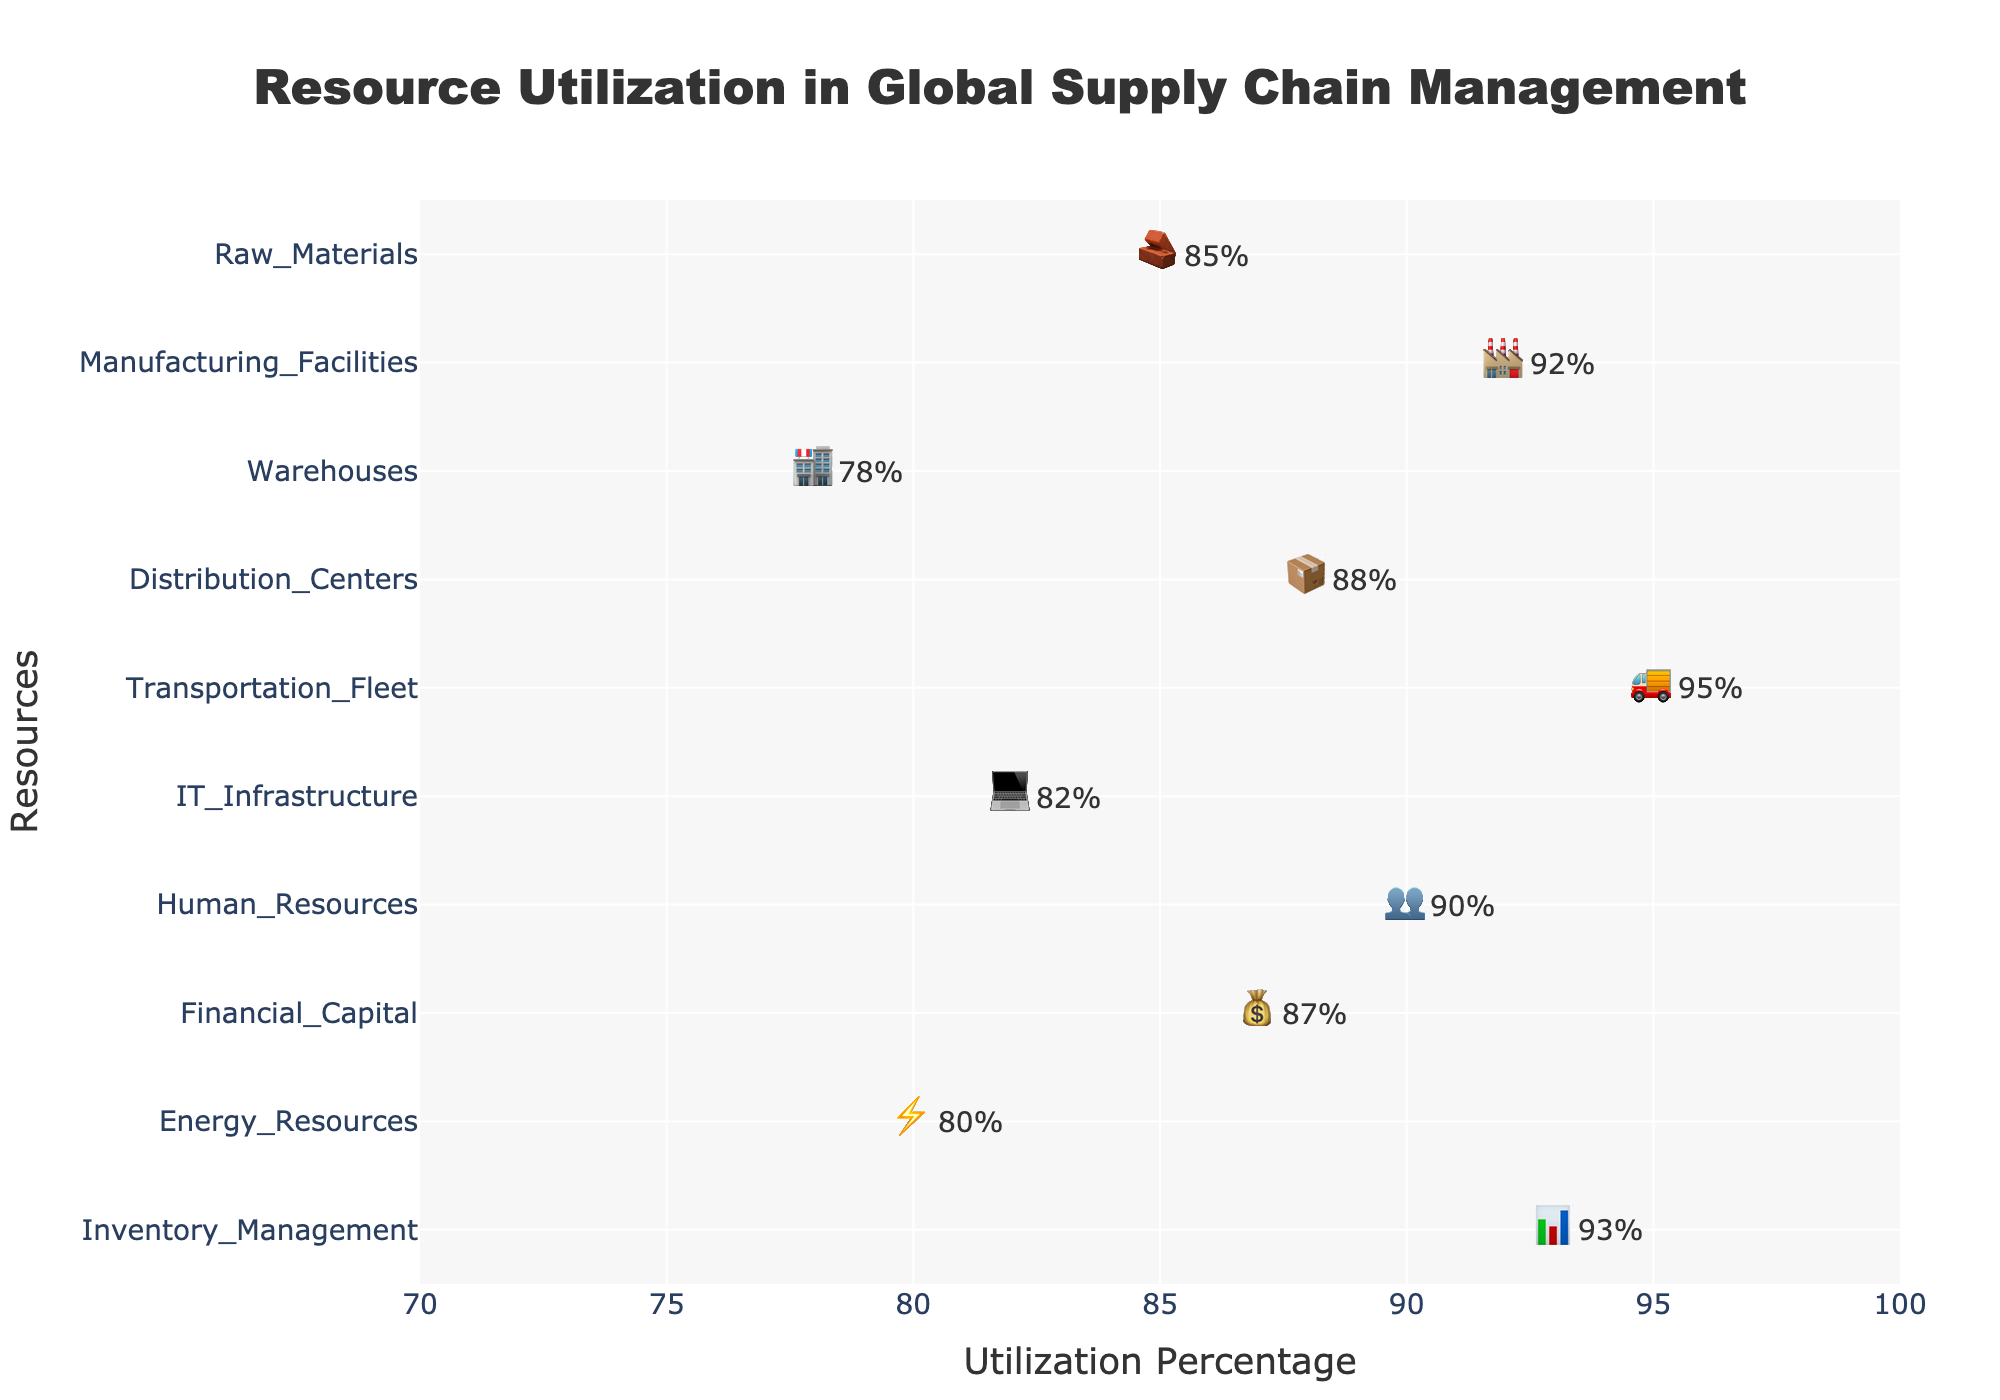What's the title of the plot? The title is prominently displayed at the top of the figure, and it provides an overview of what the plot is about.
Answer: Resource Utilization in Global Supply Chain Management What is the utilization percentage of the Transportation Fleet? The utilization percentage for each resource is displayed along with the corresponding icons. Find the row with the '🚌' icon which represents Transportation Fleet.
Answer: 95% Which resource has the highest utilization percentage? By reviewing each resource's utilization percentage, the one with the highest value will be the one with 95%.
Answer: Transportation Fleet How many resources have utilization percentages greater than 90%? Locate the resources with utilization percentages greater than 90% by examining each percentage value: Manufacturing Facilities, Distribution Centers, Transportation Fleet, Human Resources, and Inventory Management. This count results in 5.
Answer: 5 What is the average utilization percentage across all resources? To compute the average: sum all utilization percentages (85 + 92 + 78 + 88 + 95 + 82 + 90 + 87 + 80 + 93) and divide by the number of resources (10). Calculated value: (85 + 92 + 78 + 88 + 95 + 82 + 90 + 87 + 80 + 93) / 10 = 87
Answer: 87 Which resource has the lowest utilization percentage, and what is the value? By identifying and comparing all the percentages, the lowest percentage belongs to Warehouses (78%).
Answer: Warehouses, 78% What is the difference in utilization percentage between Human Resources and IT Infrastructure? Subtract the IT Infrastructure percentage (82%) from the Human Resources percentage (90%).
Answer: 8% Which resources have the same icon count? Review the resources and their icon counts: Raw Materials, Warehouses, IT Infrastructure, and Energy Resources each have 8 icons. Manufacturing Facilities, Distribution Centers, Transportation Fleet, Human Resources, Financial Capital, and Inventory Management each have 9 icons.
Answer: Raw Materials, Warehouses, IT Infrastructure, Energy Resources, Manufacturing Facilities, Distribution Centers, Transportation Fleet, Human Resources, Financial Capital, Inventory Management What is the utilization percentage of the resource with the 📦 icon? The 📦 icon represents Distribution Centers, and checking its utilization percentage gives the value.
Answer: 88% 